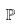Convert formula to latex. <formula><loc_0><loc_0><loc_500><loc_500>\mathbb { P }</formula> 